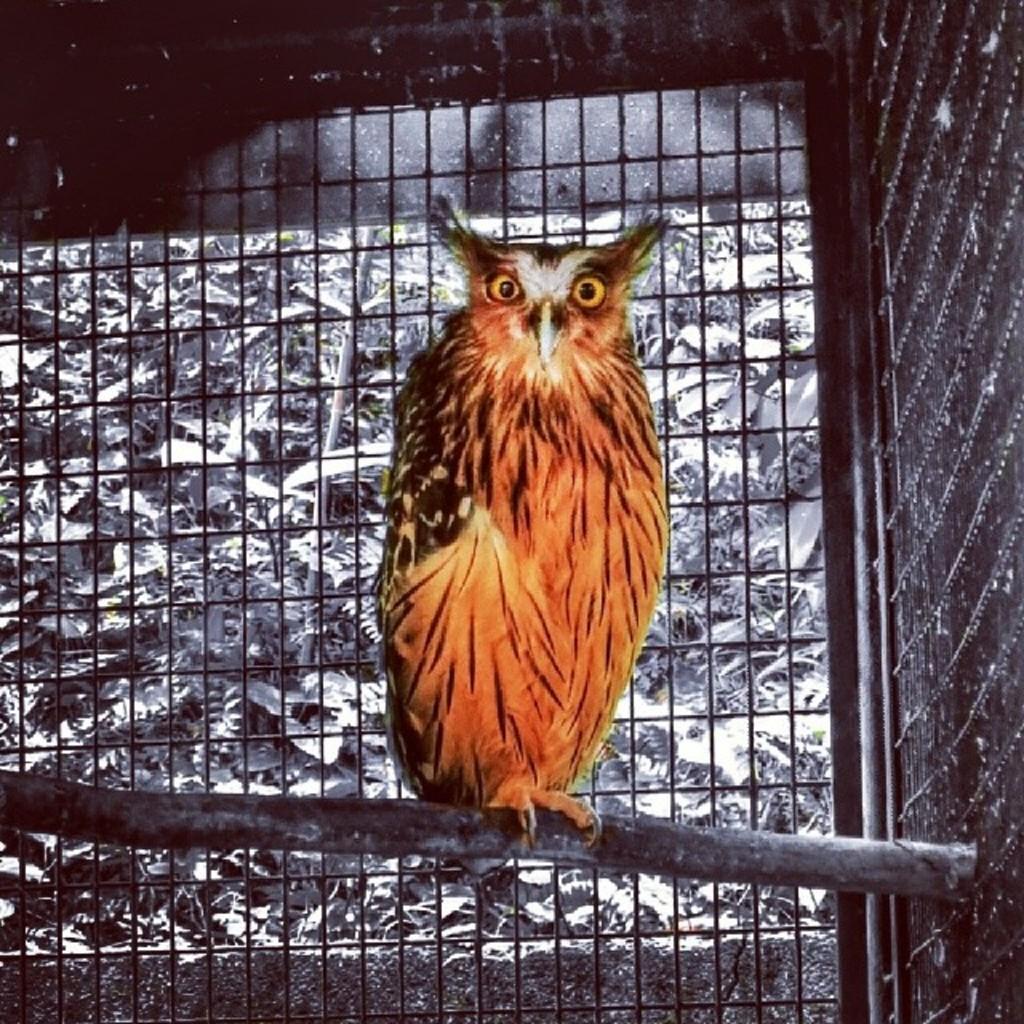In one or two sentences, can you explain what this image depicts? In the center of the image we can see an owl. In the background there is a mesh. 